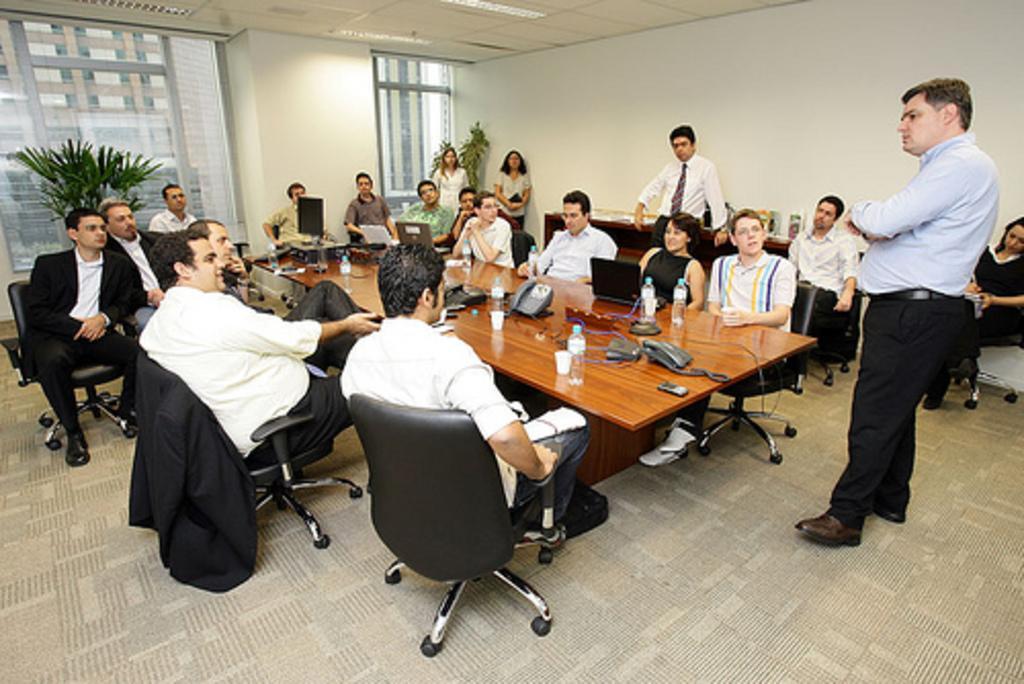Please provide a concise description of this image. In a room there are many people sitting on a black color chair. And four are standing. in those 2 are men and 2 are ladies. In front of them there is a table with telephone, glass, bottle, laptop and wire on it. To the left top corner there is a window with a tree and a pillar. And to the top corner there is another plant beside the door. 